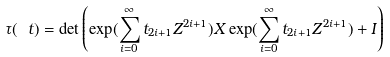Convert formula to latex. <formula><loc_0><loc_0><loc_500><loc_500>\tau ( \ t ) = \det \left ( \exp ( \sum _ { i = 0 } ^ { \infty } t _ { 2 i + 1 } Z ^ { 2 i + 1 } ) X \exp ( \sum _ { i = 0 } ^ { \infty } t _ { 2 i + 1 } Z ^ { 2 i + 1 } ) + I \right )</formula> 